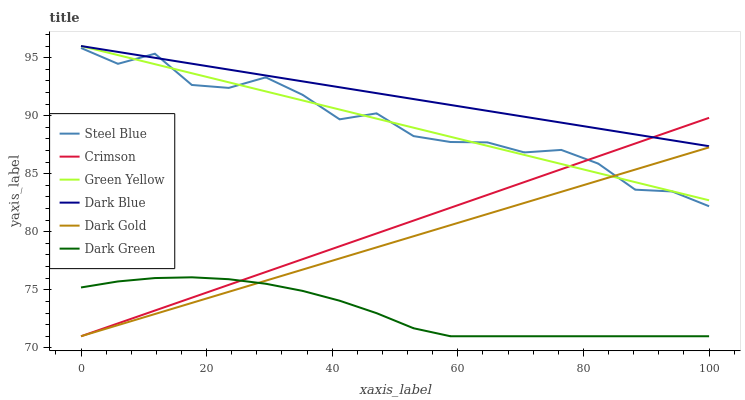Does Dark Green have the minimum area under the curve?
Answer yes or no. Yes. Does Dark Blue have the maximum area under the curve?
Answer yes or no. Yes. Does Steel Blue have the minimum area under the curve?
Answer yes or no. No. Does Steel Blue have the maximum area under the curve?
Answer yes or no. No. Is Dark Gold the smoothest?
Answer yes or no. Yes. Is Steel Blue the roughest?
Answer yes or no. Yes. Is Dark Blue the smoothest?
Answer yes or no. No. Is Dark Blue the roughest?
Answer yes or no. No. Does Dark Gold have the lowest value?
Answer yes or no. Yes. Does Steel Blue have the lowest value?
Answer yes or no. No. Does Green Yellow have the highest value?
Answer yes or no. Yes. Does Steel Blue have the highest value?
Answer yes or no. No. Is Dark Green less than Steel Blue?
Answer yes or no. Yes. Is Steel Blue greater than Dark Green?
Answer yes or no. Yes. Does Dark Blue intersect Green Yellow?
Answer yes or no. Yes. Is Dark Blue less than Green Yellow?
Answer yes or no. No. Is Dark Blue greater than Green Yellow?
Answer yes or no. No. Does Dark Green intersect Steel Blue?
Answer yes or no. No. 